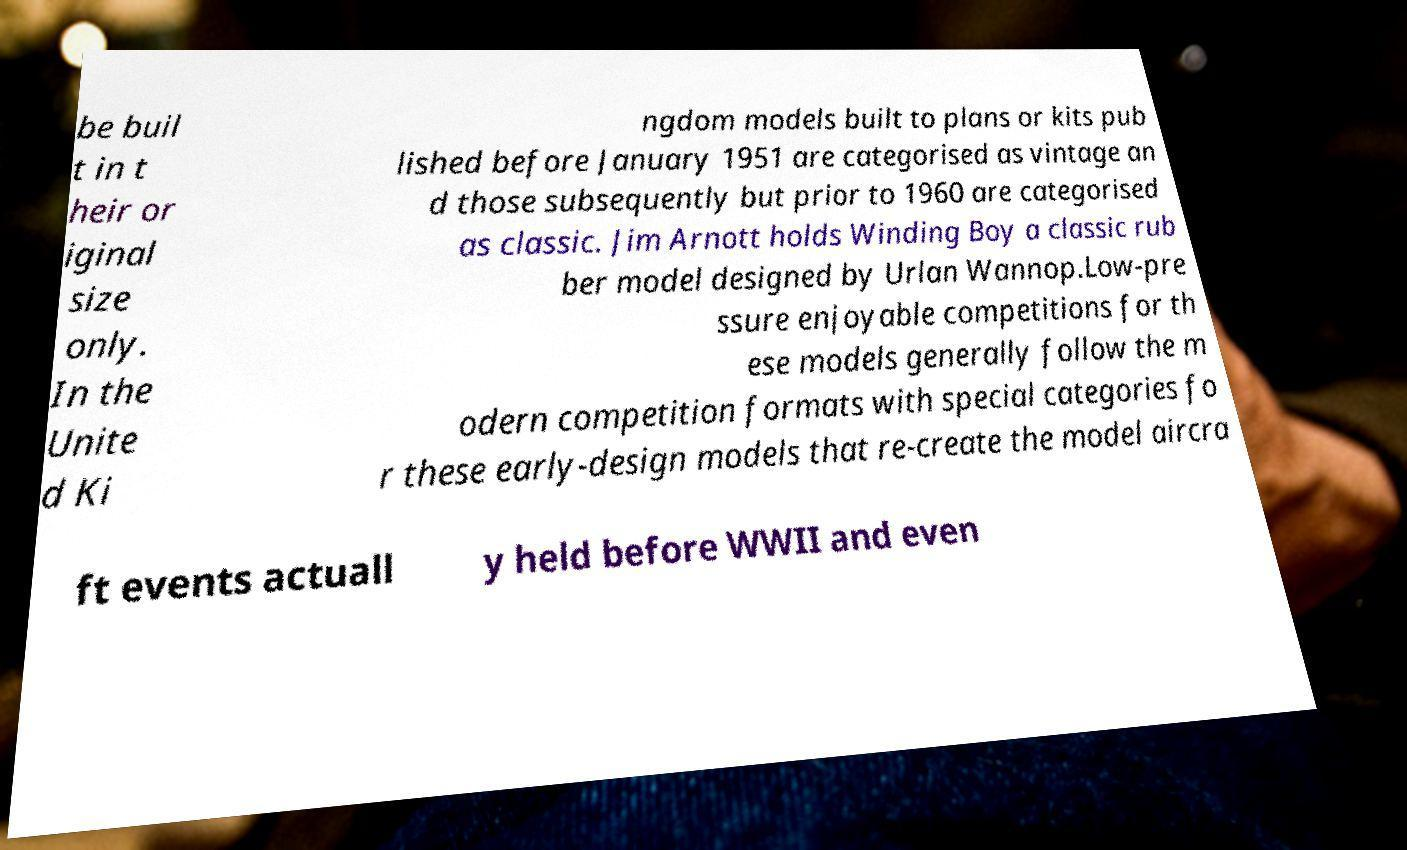There's text embedded in this image that I need extracted. Can you transcribe it verbatim? be buil t in t heir or iginal size only. In the Unite d Ki ngdom models built to plans or kits pub lished before January 1951 are categorised as vintage an d those subsequently but prior to 1960 are categorised as classic. Jim Arnott holds Winding Boy a classic rub ber model designed by Urlan Wannop.Low-pre ssure enjoyable competitions for th ese models generally follow the m odern competition formats with special categories fo r these early-design models that re-create the model aircra ft events actuall y held before WWII and even 